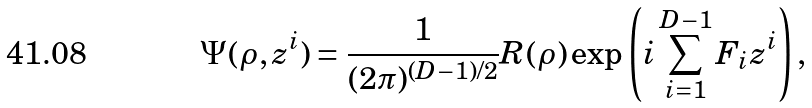<formula> <loc_0><loc_0><loc_500><loc_500>\Psi ( \rho , z ^ { i } ) = \frac { 1 } { ( 2 \pi ) ^ { ( D - 1 ) / 2 } } R ( \rho ) \exp \left ( i \sum _ { i = 1 } ^ { D - 1 } F _ { i } z ^ { i } \right ) ,</formula> 